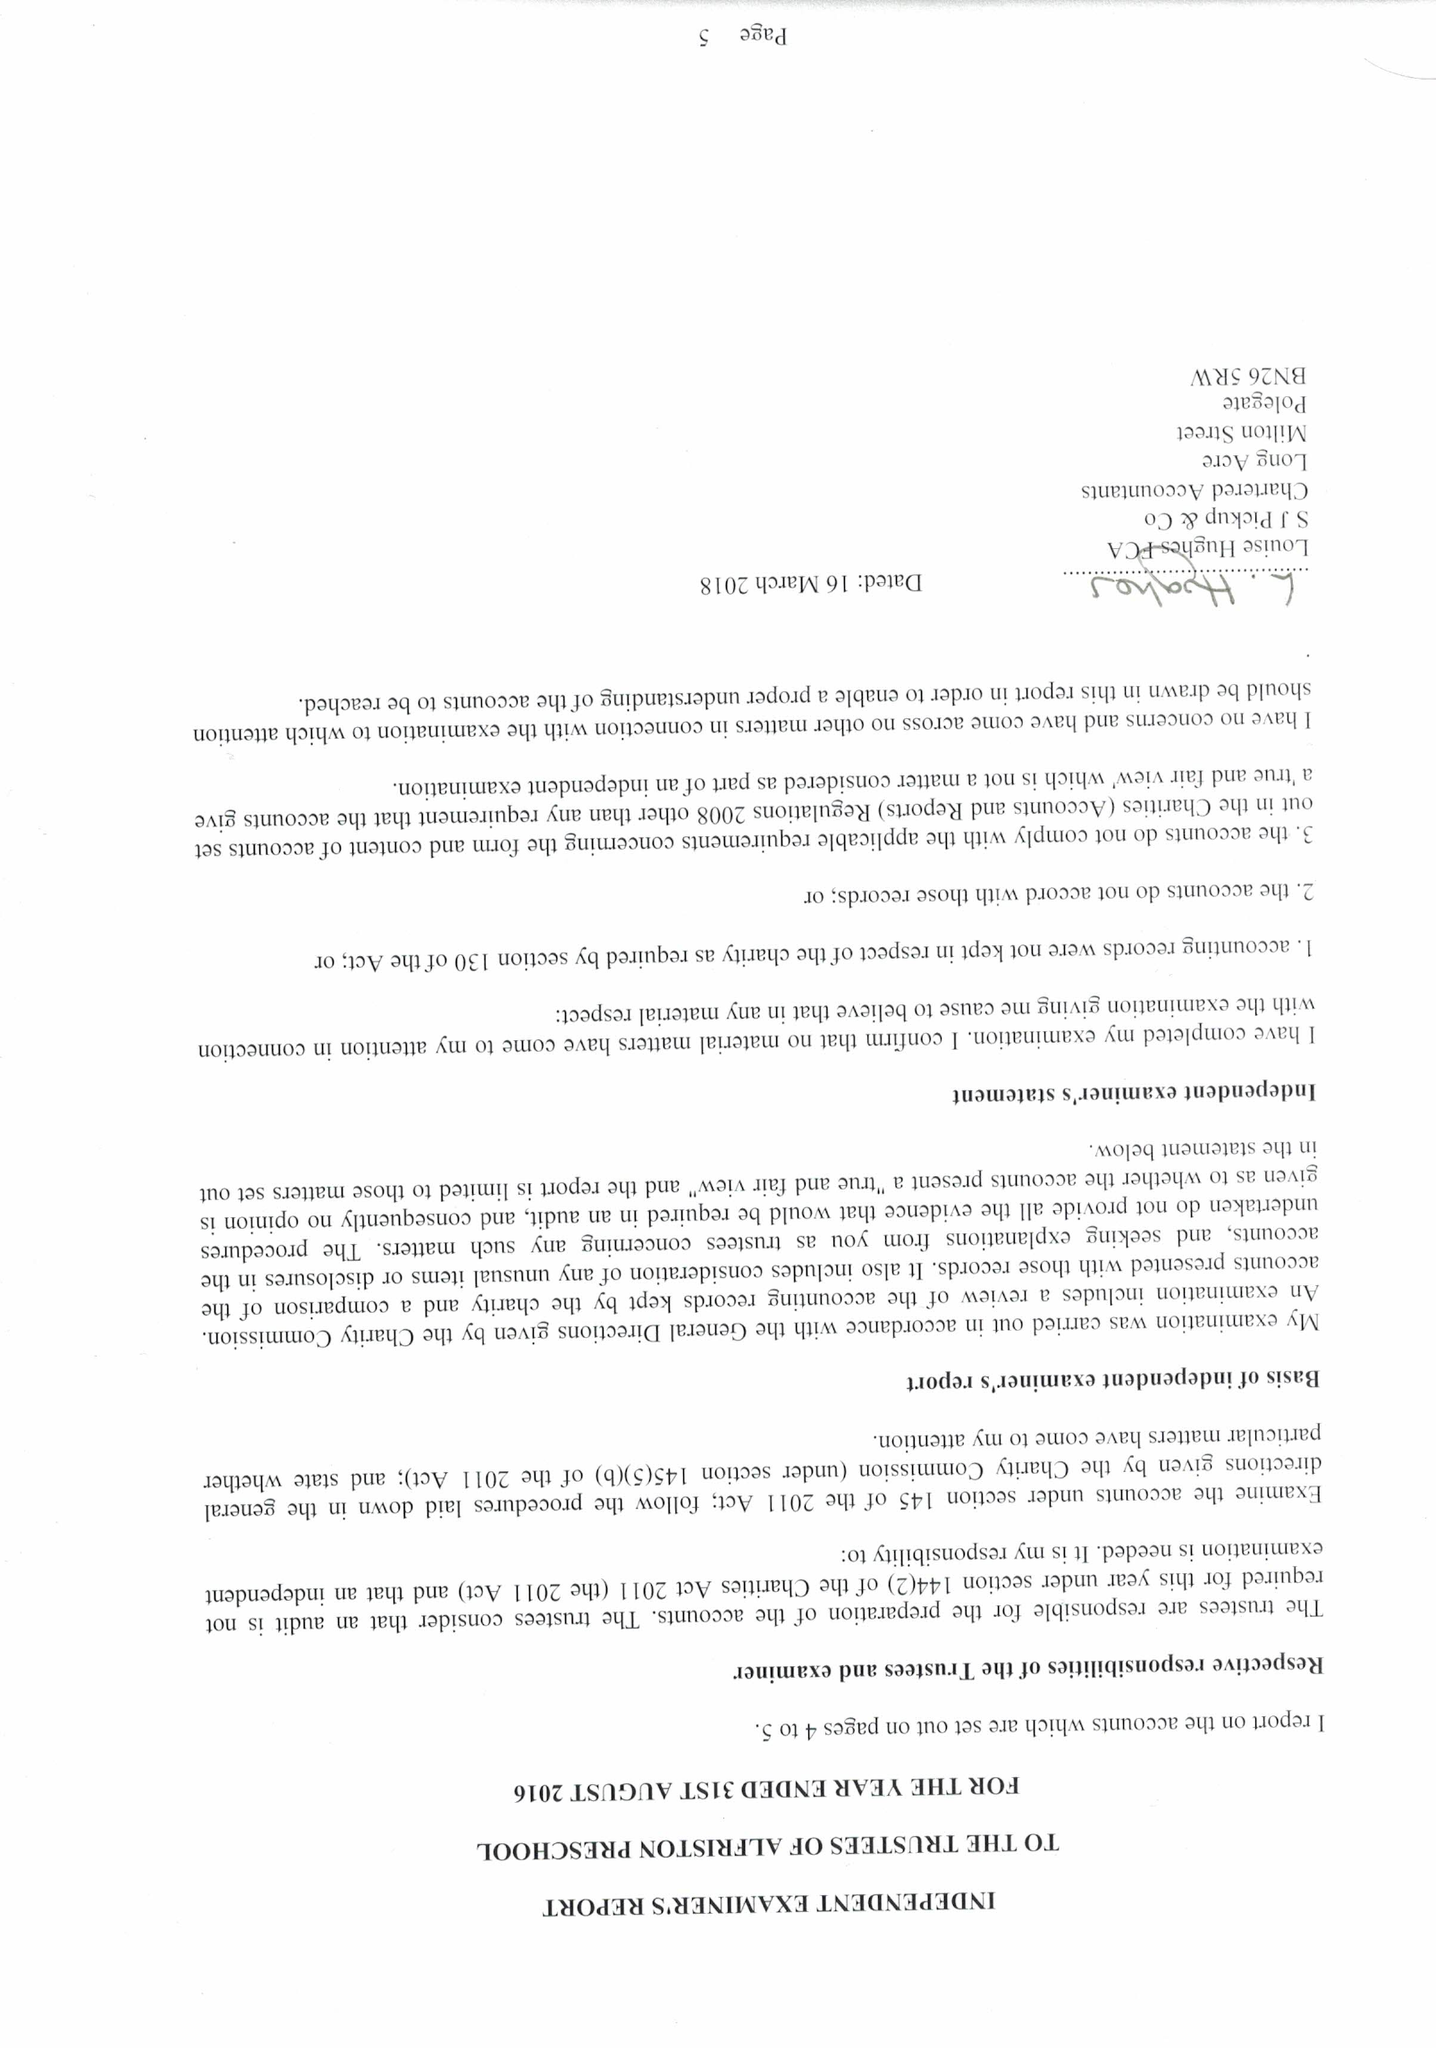What is the value for the income_annually_in_british_pounds?
Answer the question using a single word or phrase. 73190.00 